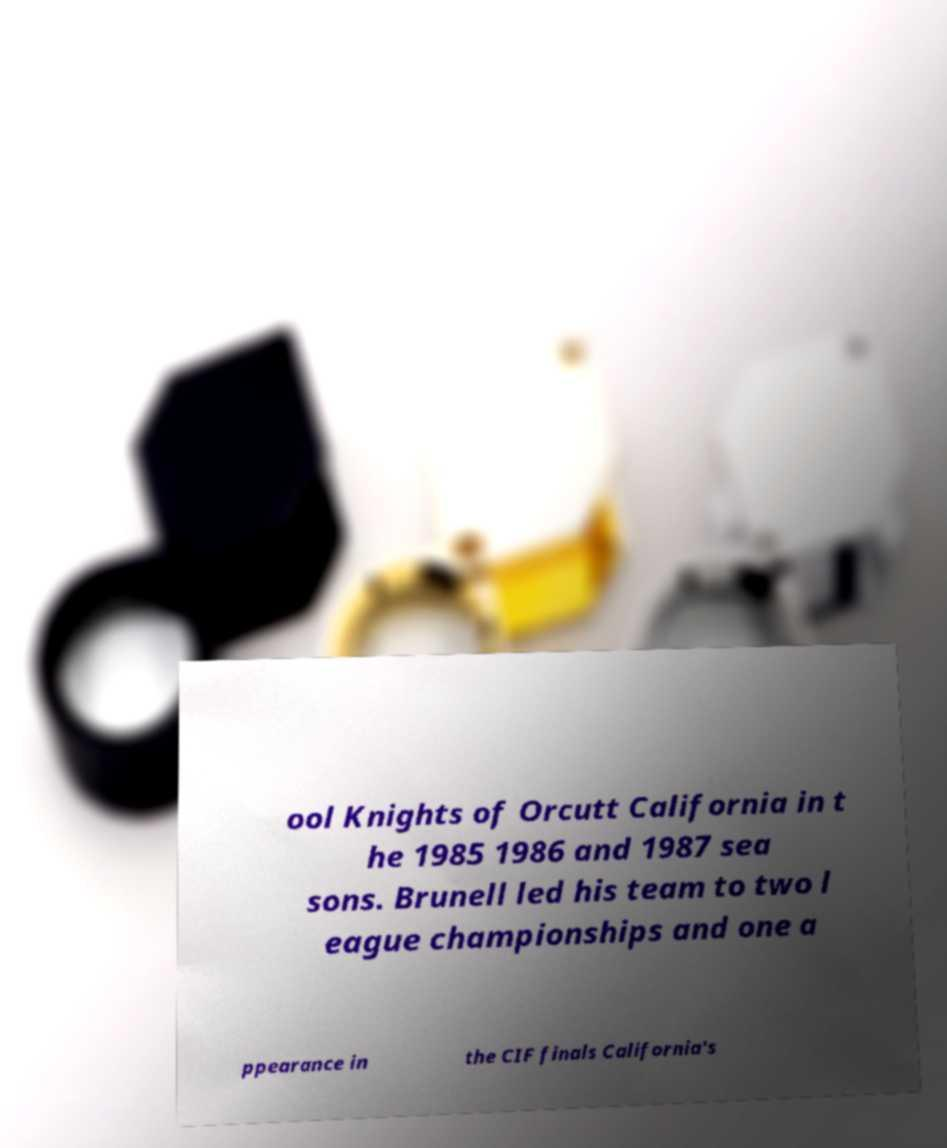Please identify and transcribe the text found in this image. ool Knights of Orcutt California in t he 1985 1986 and 1987 sea sons. Brunell led his team to two l eague championships and one a ppearance in the CIF finals California's 